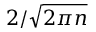<formula> <loc_0><loc_0><loc_500><loc_500>2 / { \sqrt { 2 \pi n } }</formula> 